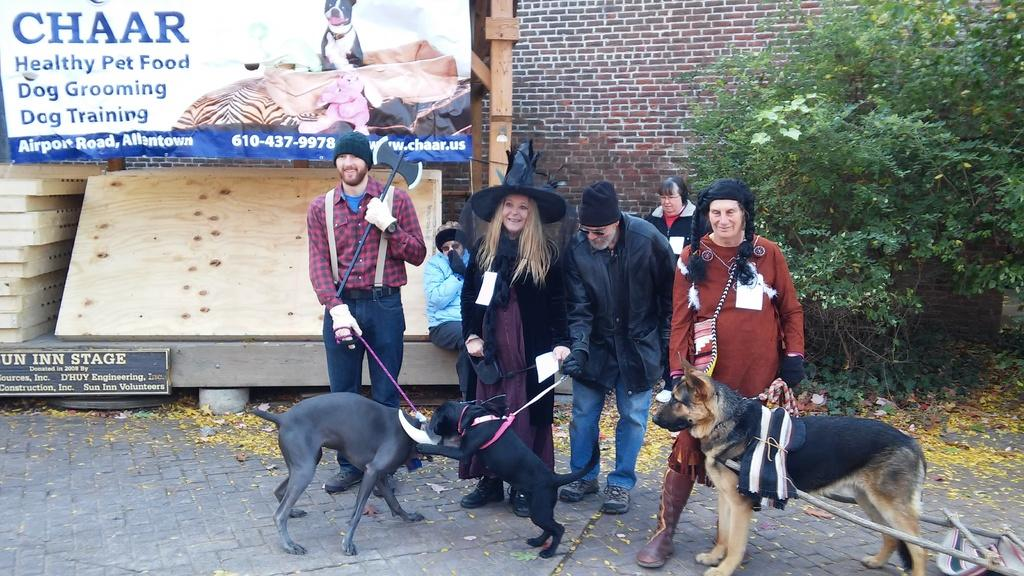How many people are in the group in the image? There is a group of people in the image, but the exact number is not specified. What are some people in the group wearing? Some people in the group are wearing costumes. What animals are present in front of the group? There are dogs in front of the group. What can be seen in the background of the image? In the background of the image, there is a hoarding, trees, and wooden planks. What type of board is being used to balance the account in the image? There is no board or mention of an account being balanced in the image. 